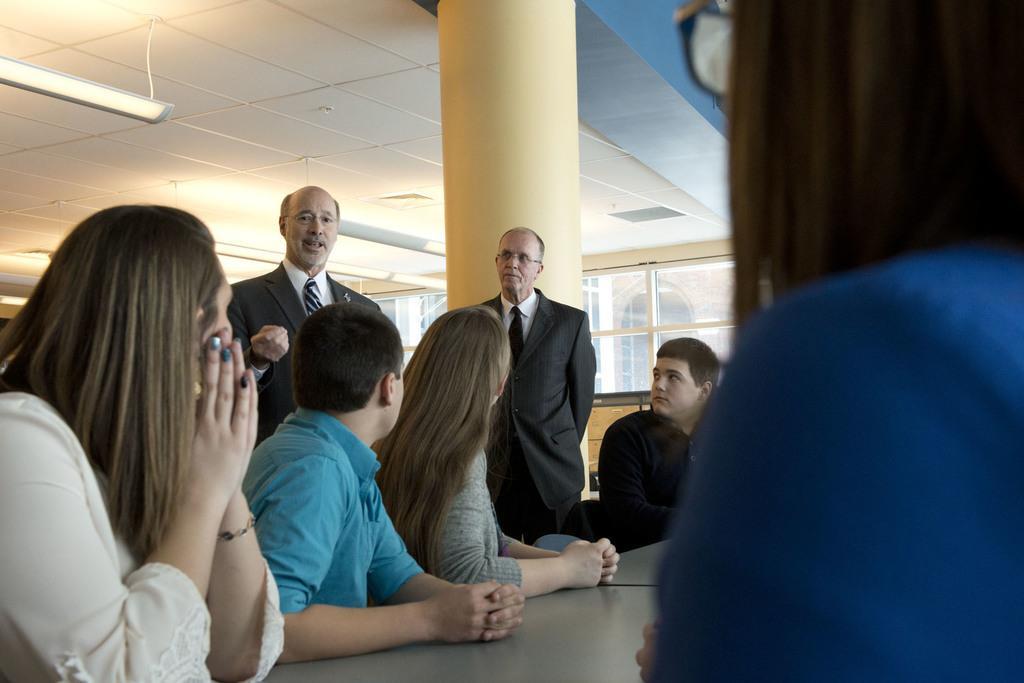Describe this image in one or two sentences. In the image we can see there are people sitting and two of them are standing, they are wearing clothes and some of them are wearing speculates. Here we can see the pillar, light and the glass window. 